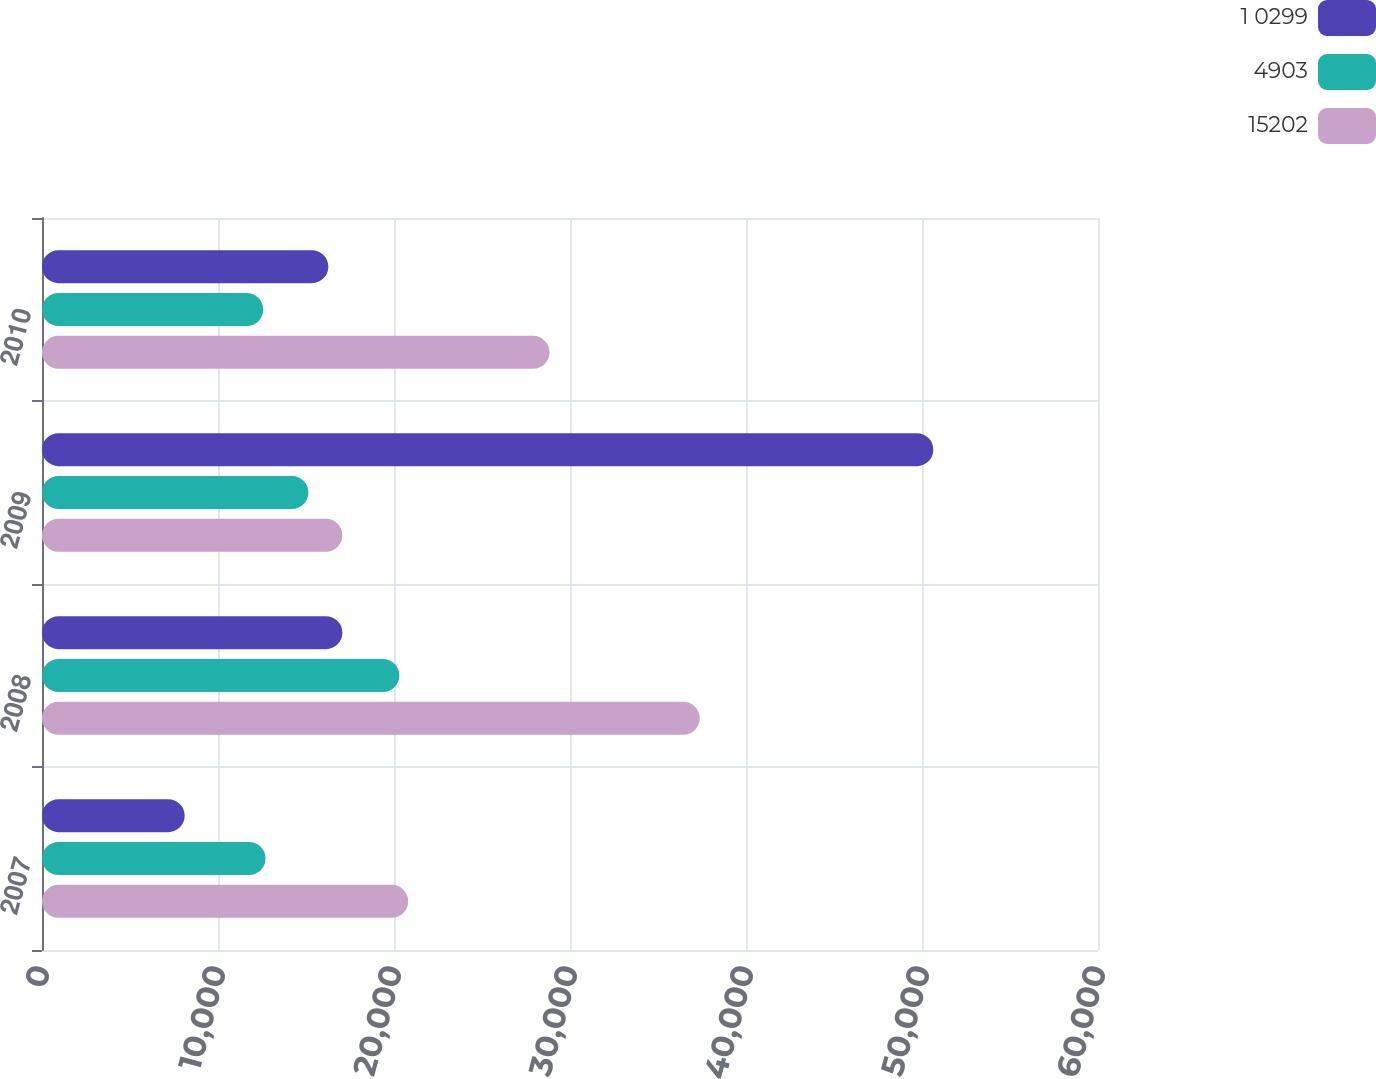Convert chart to OTSL. <chart><loc_0><loc_0><loc_500><loc_500><stacked_bar_chart><ecel><fcel>2007<fcel>2008<fcel>2009<fcel>2010<nl><fcel>1 0299<fcel>8106<fcel>17068<fcel>50643<fcel>16268<nl><fcel>4903<fcel>12700<fcel>20304<fcel>15133<fcel>12568<nl><fcel>15202<fcel>20806<fcel>37372<fcel>17068<fcel>28836<nl></chart> 